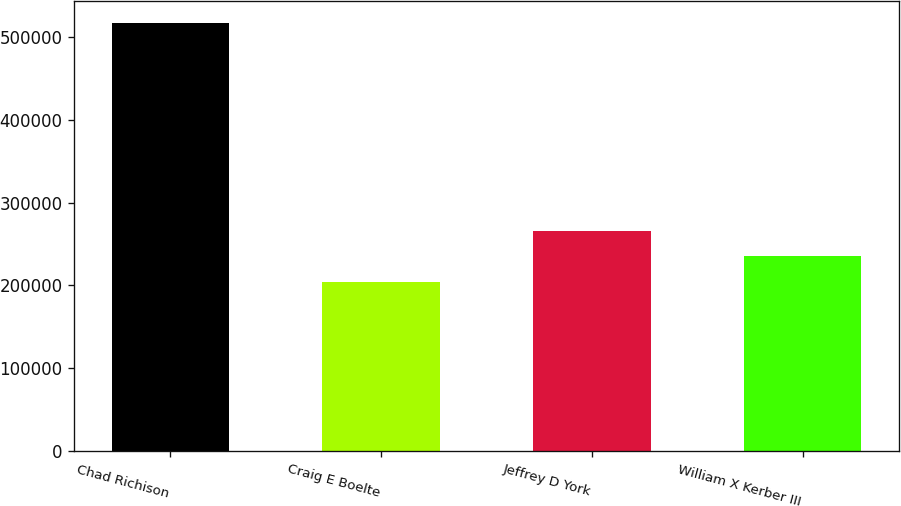Convert chart. <chart><loc_0><loc_0><loc_500><loc_500><bar_chart><fcel>Chad Richison<fcel>Craig E Boelte<fcel>Jeffrey D York<fcel>William X Kerber III<nl><fcel>516921<fcel>203623<fcel>266283<fcel>234953<nl></chart> 